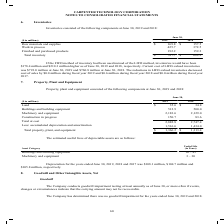According to Carpenter Technology's financial document, What was the amount of Land in 2019? According to the financial document, $35.6. The relevant text states: "($ in millions) 2019 2018 Land $ 35.6 $ 34.8 Buildings and building equipment 512.9 500.0 Machinery and equipment 2,183.6 2,129.0 Constru..." Also, What was the amount of  Buildings and building equipment in 2018? According to the financial document, 500.0. The relevant text states: "5.6 $ 34.8 Buildings and building equipment 512.9 500.0 Machinery and equipment 2,183.6 2,129.0 Construction in progress 150.7 83.6 Total at cost 2,882.8 2..." Also, In which years was Property, Plant and Equipment calculated? The document shows two values: 2019 and 2018. From the document: "June 30, ($ in millions) 2019 2018 Raw materials and supplies $ 169.8 $ 157.5 Work in process 425.7 372.5 Finished and purchased June 30, ($ in millio..." Additionally, In which year was the amount of Land larger? According to the financial document, 2019. The relevant text states: "June 30, ($ in millions) 2019 2018 Raw materials and supplies $ 169.8 $ 157.5 Work in process 425.7 372.5 Finished and purchased..." Also, can you calculate: What was the change in Buildings and building equipment in 2019 from 2018? Based on the calculation: 512.9-500.0, the result is 12.9 (in millions). This is based on the information: "5.6 $ 34.8 Buildings and building equipment 512.9 500.0 Machinery and equipment 2,183.6 2,129.0 Construction in progress 150.7 83.6 Total at cost 2,882.8 2 nd $ 35.6 $ 34.8 Buildings and building equi..." The key data points involved are: 500.0, 512.9. Also, can you calculate: What was the percentage change in Buildings and building equipment in 2019 from 2018? To answer this question, I need to perform calculations using the financial data. The calculation is: (512.9-500.0)/500.0, which equals 2.58 (percentage). This is based on the information: "5.6 $ 34.8 Buildings and building equipment 512.9 500.0 Machinery and equipment 2,183.6 2,129.0 Construction in progress 150.7 83.6 Total at cost 2,882.8 2 nd $ 35.6 $ 34.8 Buildings and building equi..." The key data points involved are: 500.0, 512.9. 